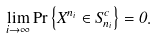Convert formula to latex. <formula><loc_0><loc_0><loc_500><loc_500>\lim _ { i \rightarrow \infty } \Pr \left \{ X ^ { n _ { i } } \in S _ { n _ { i } } ^ { c } \right \} = 0 .</formula> 